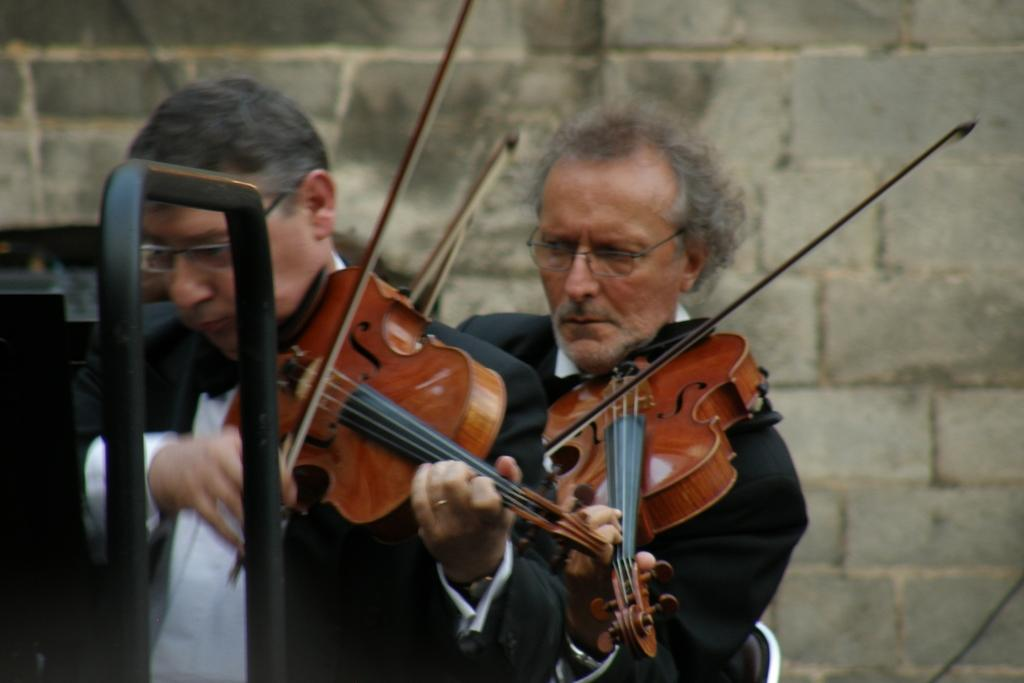How many musicians are present in the image? There are two musicians in the image. What instruments are the musicians playing? Both musicians are playing violins. What type of linen is being used to create the sound from the violins in the image? There is no mention of linen in the image, and it is not related to the sound produced by violins. 